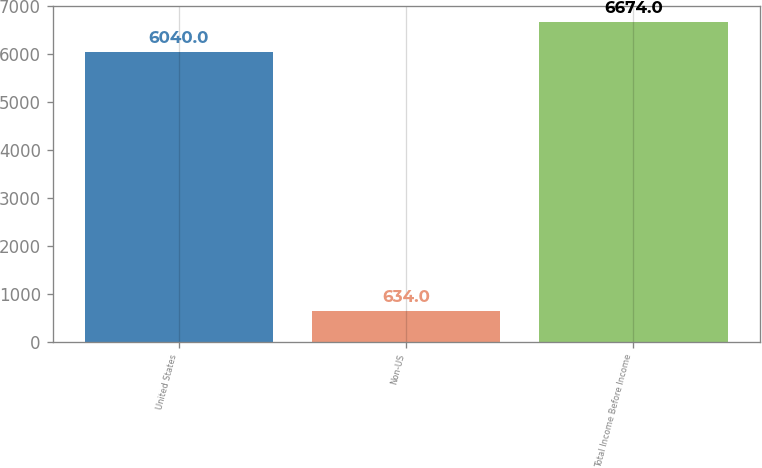Convert chart to OTSL. <chart><loc_0><loc_0><loc_500><loc_500><bar_chart><fcel>United States<fcel>Non-US<fcel>Total Income Before Income<nl><fcel>6040<fcel>634<fcel>6674<nl></chart> 